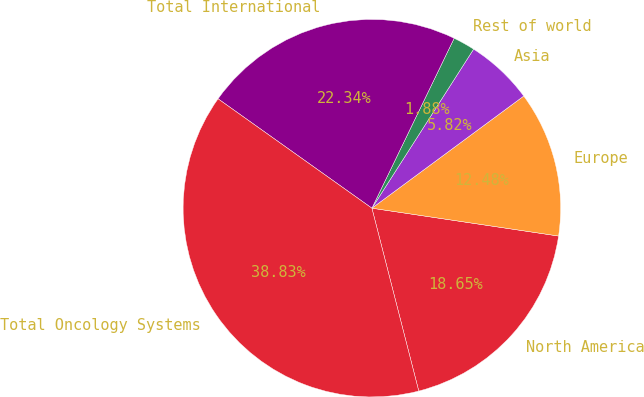Convert chart to OTSL. <chart><loc_0><loc_0><loc_500><loc_500><pie_chart><fcel>North America<fcel>Europe<fcel>Asia<fcel>Rest of world<fcel>Total International<fcel>Total Oncology Systems<nl><fcel>18.65%<fcel>12.48%<fcel>5.82%<fcel>1.88%<fcel>22.34%<fcel>38.83%<nl></chart> 